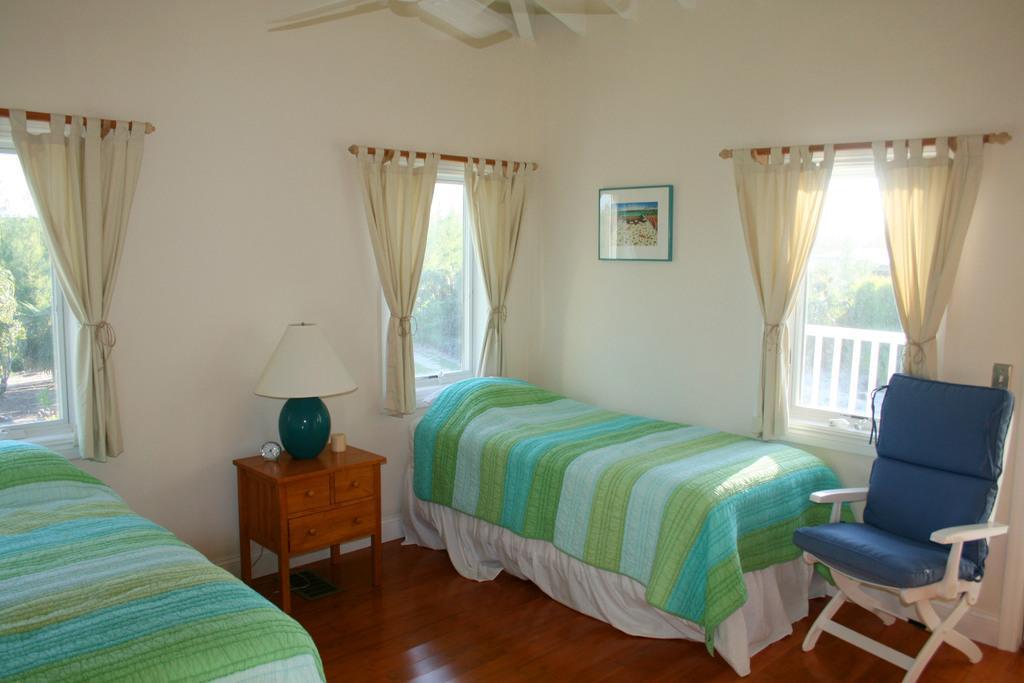Can you describe this image briefly? In this picture we can see bedchair, windows with curtains, table, lamp, clock, frame, wall and from window we can see trees. 